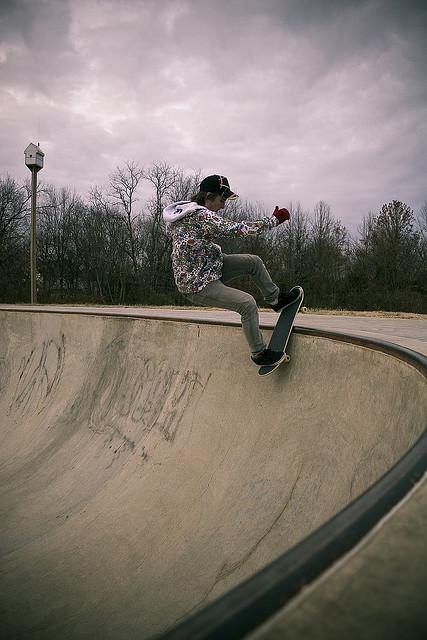What is the man doing?
Give a very brief answer. Skateboarding. Why is there a ditch?
Concise answer only. Skateboarding. Is it probably warm or cold out?
Short answer required. Cold. Is this boy in danger of injuring himself with this stunt?
Write a very short answer. Yes. What small structure is behind the skater?
Short answer required. Birdhouse. 